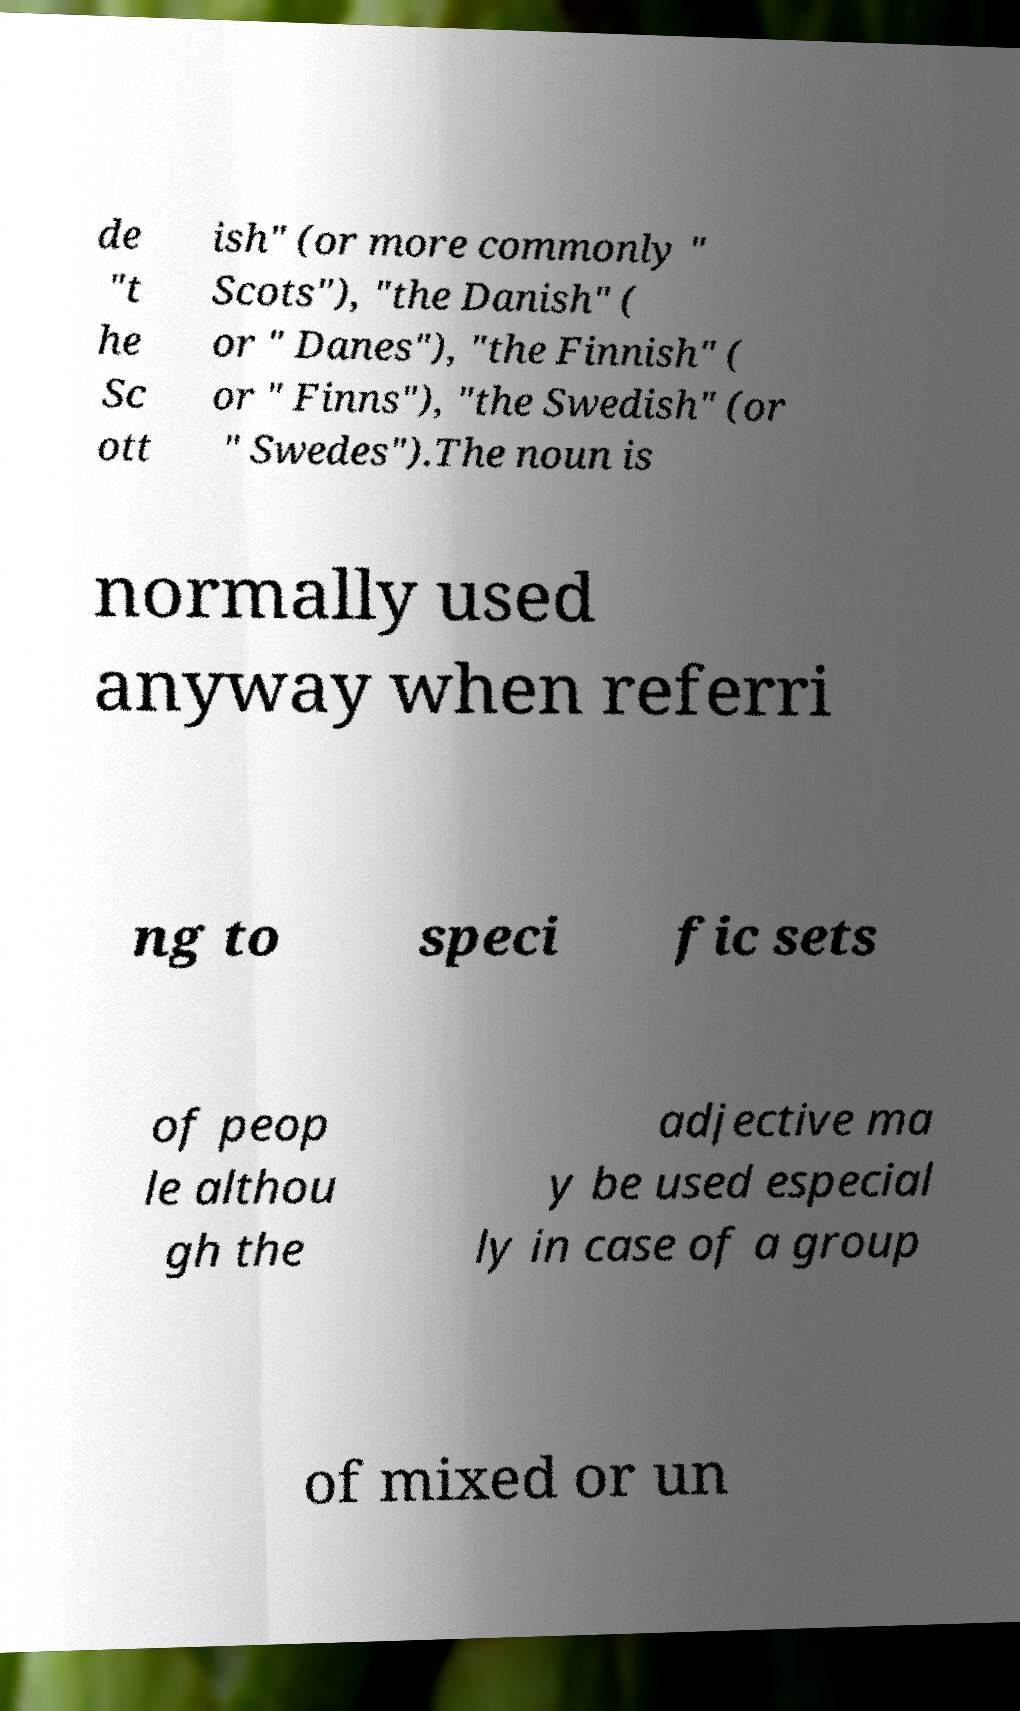Can you accurately transcribe the text from the provided image for me? de "t he Sc ott ish" (or more commonly " Scots"), "the Danish" ( or " Danes"), "the Finnish" ( or " Finns"), "the Swedish" (or " Swedes").The noun is normally used anyway when referri ng to speci fic sets of peop le althou gh the adjective ma y be used especial ly in case of a group of mixed or un 